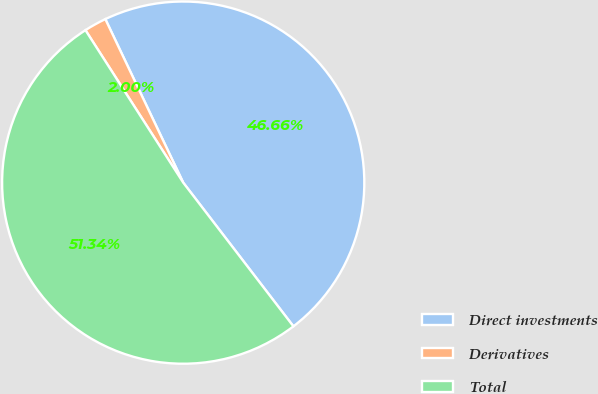Convert chart. <chart><loc_0><loc_0><loc_500><loc_500><pie_chart><fcel>Direct investments<fcel>Derivatives<fcel>Total<nl><fcel>46.66%<fcel>2.0%<fcel>51.33%<nl></chart> 